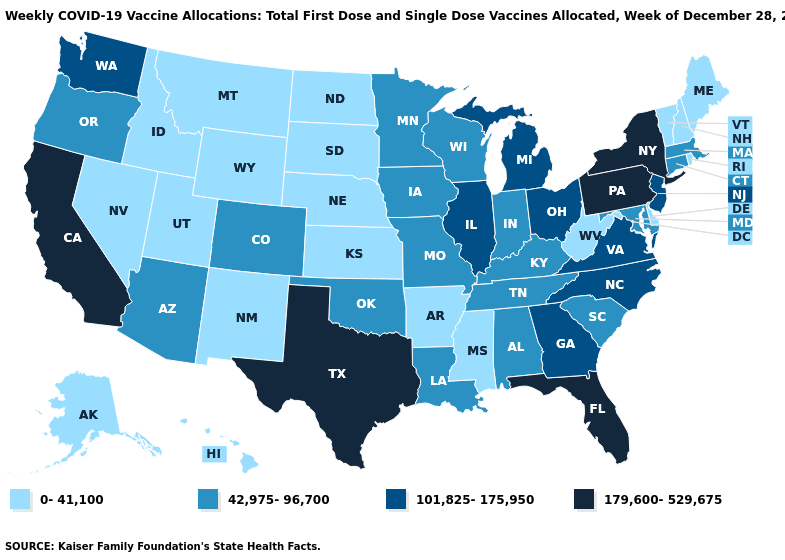Name the states that have a value in the range 179,600-529,675?
Keep it brief. California, Florida, New York, Pennsylvania, Texas. How many symbols are there in the legend?
Answer briefly. 4. What is the highest value in the MidWest ?
Quick response, please. 101,825-175,950. Among the states that border Michigan , does Ohio have the highest value?
Quick response, please. Yes. What is the value of Kansas?
Keep it brief. 0-41,100. What is the value of Texas?
Short answer required. 179,600-529,675. What is the lowest value in the USA?
Quick response, please. 0-41,100. What is the value of Virginia?
Be succinct. 101,825-175,950. How many symbols are there in the legend?
Give a very brief answer. 4. What is the value of Indiana?
Keep it brief. 42,975-96,700. Name the states that have a value in the range 42,975-96,700?
Give a very brief answer. Alabama, Arizona, Colorado, Connecticut, Indiana, Iowa, Kentucky, Louisiana, Maryland, Massachusetts, Minnesota, Missouri, Oklahoma, Oregon, South Carolina, Tennessee, Wisconsin. What is the highest value in the Northeast ?
Concise answer only. 179,600-529,675. Name the states that have a value in the range 101,825-175,950?
Write a very short answer. Georgia, Illinois, Michigan, New Jersey, North Carolina, Ohio, Virginia, Washington. How many symbols are there in the legend?
Answer briefly. 4. Which states hav the highest value in the Northeast?
Answer briefly. New York, Pennsylvania. 